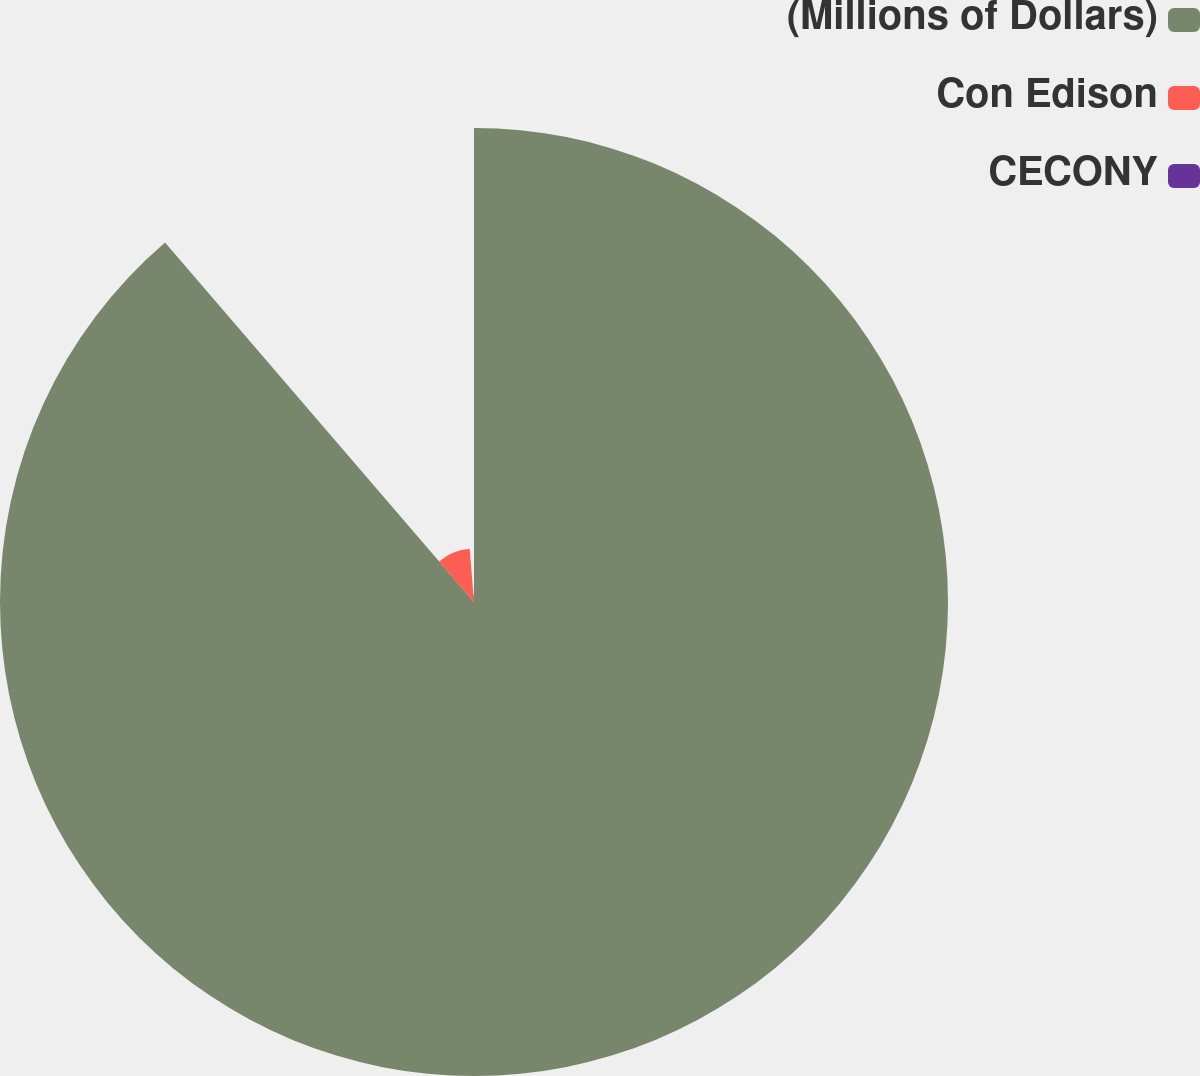Convert chart. <chart><loc_0><loc_0><loc_500><loc_500><pie_chart><fcel>(Millions of Dollars)<fcel>Con Edison<fcel>CECONY<nl><fcel>88.7%<fcel>10.02%<fcel>1.28%<nl></chart> 